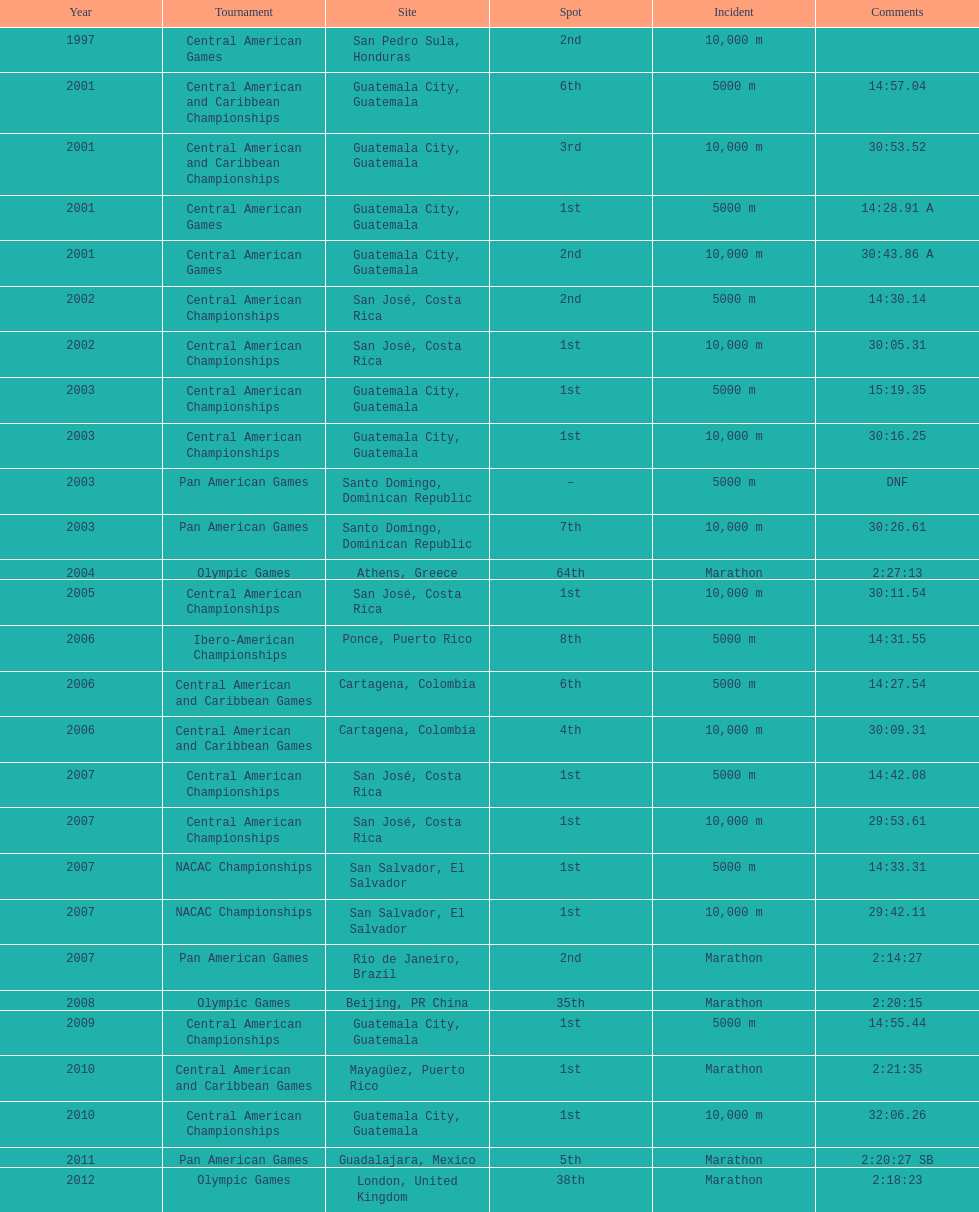What was the first competition this competitor competed in? Central American Games. Could you parse the entire table as a dict? {'header': ['Year', 'Tournament', 'Site', 'Spot', 'Incident', 'Comments'], 'rows': [['1997', 'Central American Games', 'San Pedro Sula, Honduras', '2nd', '10,000 m', ''], ['2001', 'Central American and Caribbean Championships', 'Guatemala City, Guatemala', '6th', '5000 m', '14:57.04'], ['2001', 'Central American and Caribbean Championships', 'Guatemala City, Guatemala', '3rd', '10,000 m', '30:53.52'], ['2001', 'Central American Games', 'Guatemala City, Guatemala', '1st', '5000 m', '14:28.91 A'], ['2001', 'Central American Games', 'Guatemala City, Guatemala', '2nd', '10,000 m', '30:43.86 A'], ['2002', 'Central American Championships', 'San José, Costa Rica', '2nd', '5000 m', '14:30.14'], ['2002', 'Central American Championships', 'San José, Costa Rica', '1st', '10,000 m', '30:05.31'], ['2003', 'Central American Championships', 'Guatemala City, Guatemala', '1st', '5000 m', '15:19.35'], ['2003', 'Central American Championships', 'Guatemala City, Guatemala', '1st', '10,000 m', '30:16.25'], ['2003', 'Pan American Games', 'Santo Domingo, Dominican Republic', '–', '5000 m', 'DNF'], ['2003', 'Pan American Games', 'Santo Domingo, Dominican Republic', '7th', '10,000 m', '30:26.61'], ['2004', 'Olympic Games', 'Athens, Greece', '64th', 'Marathon', '2:27:13'], ['2005', 'Central American Championships', 'San José, Costa Rica', '1st', '10,000 m', '30:11.54'], ['2006', 'Ibero-American Championships', 'Ponce, Puerto Rico', '8th', '5000 m', '14:31.55'], ['2006', 'Central American and Caribbean Games', 'Cartagena, Colombia', '6th', '5000 m', '14:27.54'], ['2006', 'Central American and Caribbean Games', 'Cartagena, Colombia', '4th', '10,000 m', '30:09.31'], ['2007', 'Central American Championships', 'San José, Costa Rica', '1st', '5000 m', '14:42.08'], ['2007', 'Central American Championships', 'San José, Costa Rica', '1st', '10,000 m', '29:53.61'], ['2007', 'NACAC Championships', 'San Salvador, El Salvador', '1st', '5000 m', '14:33.31'], ['2007', 'NACAC Championships', 'San Salvador, El Salvador', '1st', '10,000 m', '29:42.11'], ['2007', 'Pan American Games', 'Rio de Janeiro, Brazil', '2nd', 'Marathon', '2:14:27'], ['2008', 'Olympic Games', 'Beijing, PR China', '35th', 'Marathon', '2:20:15'], ['2009', 'Central American Championships', 'Guatemala City, Guatemala', '1st', '5000 m', '14:55.44'], ['2010', 'Central American and Caribbean Games', 'Mayagüez, Puerto Rico', '1st', 'Marathon', '2:21:35'], ['2010', 'Central American Championships', 'Guatemala City, Guatemala', '1st', '10,000 m', '32:06.26'], ['2011', 'Pan American Games', 'Guadalajara, Mexico', '5th', 'Marathon', '2:20:27 SB'], ['2012', 'Olympic Games', 'London, United Kingdom', '38th', 'Marathon', '2:18:23']]} 